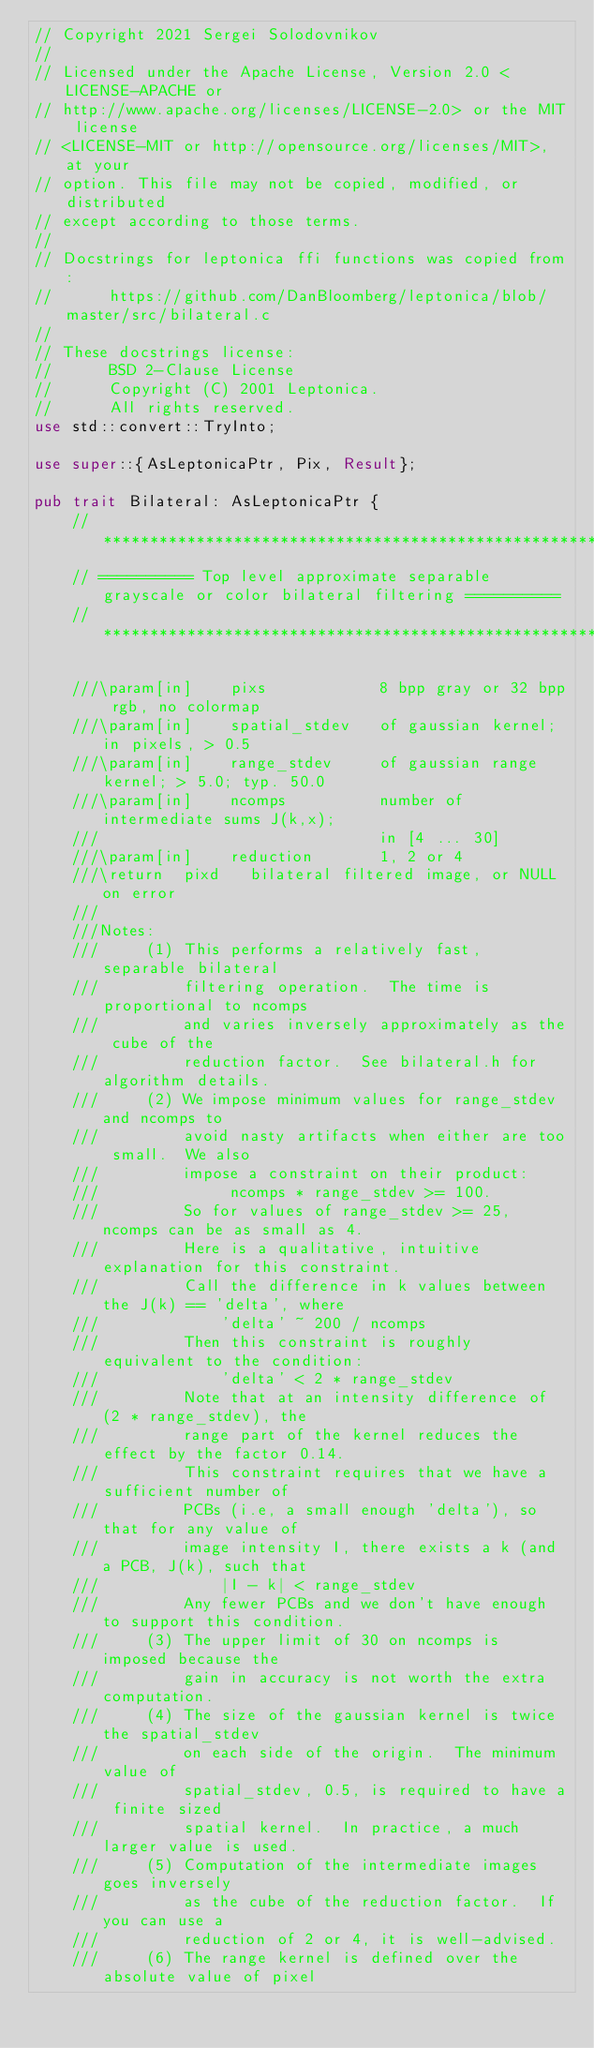<code> <loc_0><loc_0><loc_500><loc_500><_Rust_>// Copyright 2021 Sergei Solodovnikov
//
// Licensed under the Apache License, Version 2.0 <LICENSE-APACHE or
// http://www.apache.org/licenses/LICENSE-2.0> or the MIT license
// <LICENSE-MIT or http://opensource.org/licenses/MIT>, at your
// option. This file may not be copied, modified, or distributed
// except according to those terms.
//
// Docstrings for leptonica ffi functions was copied from: 
//      https://github.com/DanBloomberg/leptonica/blob/master/src/bilateral.c
//
// These docstrings license:
//      BSD 2-Clause License
//      Copyright (C) 2001 Leptonica. 
//      All rights reserved.
use std::convert::TryInto;

use super::{AsLeptonicaPtr, Pix, Result};

pub trait Bilateral: AsLeptonicaPtr {
    //*********************************************************************************************
    // ========== Top level approximate separable grayscale or color bilateral filtering ==========
    //*********************************************************************************************

    ///\param[in]    pixs            8 bpp gray or 32 bpp rgb, no colormap
    ///\param[in]    spatial_stdev   of gaussian kernel; in pixels, > 0.5
    ///\param[in]    range_stdev     of gaussian range kernel; > 5.0; typ. 50.0
    ///\param[in]    ncomps          number of intermediate sums J(k,x);
    ///                              in [4 ... 30]
    ///\param[in]    reduction       1, 2 or 4
    ///\return  pixd   bilateral filtered image, or NULL on error
    ///
    ///Notes:
    ///     (1) This performs a relatively fast, separable bilateral
    ///         filtering operation.  The time is proportional to ncomps
    ///         and varies inversely approximately as the cube of the
    ///         reduction factor.  See bilateral.h for algorithm details.
    ///     (2) We impose minimum values for range_stdev and ncomps to
    ///         avoid nasty artifacts when either are too small.  We also
    ///         impose a constraint on their product:
    ///              ncomps * range_stdev >= 100.
    ///         So for values of range_stdev >= 25, ncomps can be as small as 4.
    ///         Here is a qualitative, intuitive explanation for this constraint.
    ///         Call the difference in k values between the J(k) == 'delta', where
    ///             'delta' ~ 200 / ncomps
    ///         Then this constraint is roughly equivalent to the condition:
    ///             'delta' < 2 * range_stdev
    ///         Note that at an intensity difference of (2 * range_stdev), the
    ///         range part of the kernel reduces the effect by the factor 0.14.
    ///         This constraint requires that we have a sufficient number of
    ///         PCBs (i.e, a small enough 'delta'), so that for any value of
    ///         image intensity I, there exists a k (and a PCB, J(k), such that
    ///             |I - k| < range_stdev
    ///         Any fewer PCBs and we don't have enough to support this condition.
    ///     (3) The upper limit of 30 on ncomps is imposed because the
    ///         gain in accuracy is not worth the extra computation.
    ///     (4) The size of the gaussian kernel is twice the spatial_stdev
    ///         on each side of the origin.  The minimum value of
    ///         spatial_stdev, 0.5, is required to have a finite sized
    ///         spatial kernel.  In practice, a much larger value is used.
    ///     (5) Computation of the intermediate images goes inversely
    ///         as the cube of the reduction factor.  If you can use a
    ///         reduction of 2 or 4, it is well-advised.
    ///     (6) The range kernel is defined over the absolute value of pixel</code> 